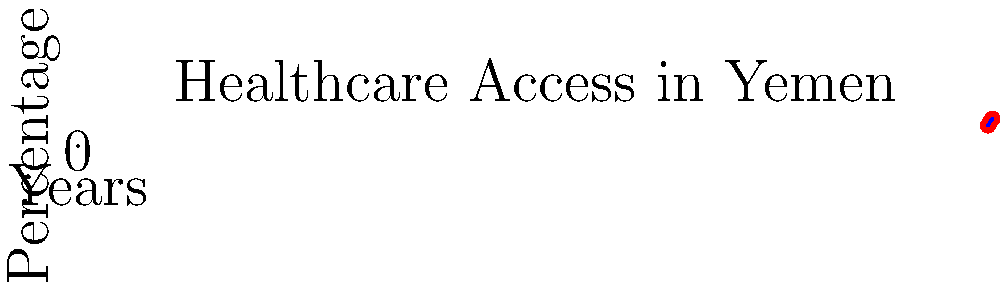Based on the infographic showing healthcare access trends in Yemen from 2010 to 2020, what was the approximate percentage increase in healthcare access between 2010 and 2020? To calculate the percentage increase in healthcare access between 2010 and 2020:

1. Identify the healthcare access percentages:
   - 2010: 45%
   - 2020: 60%

2. Calculate the difference:
   $60\% - 45\% = 15\%$

3. Calculate the percentage increase:
   $\frac{\text{Increase}}{\text{Original Value}} \times 100\% = \frac{15\%}{45\%} \times 100\% = 33.33\%$

Therefore, the approximate percentage increase in healthcare access between 2010 and 2020 was 33.33%.
Answer: 33.33% 